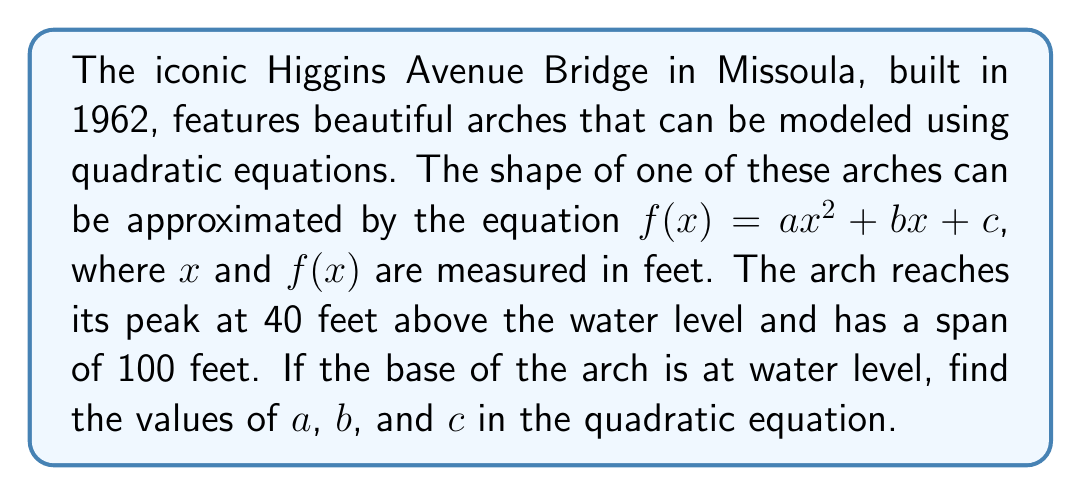Show me your answer to this math problem. Let's approach this step-by-step:

1) The arch is symmetrical, so its axis of symmetry is at the midpoint of its span. The span is 100 feet, so the axis of symmetry is at $x = 50$ feet.

2) We know three points on this parabola:
   - Left endpoint: $(0, 0)$
   - Vertex: $(50, 40)$
   - Right endpoint: $(100, 0)$

3) For a quadratic function $f(x) = ax^2 + bx + c$, the axis of symmetry is given by $x = -\frac{b}{2a}$. Since we know the axis of symmetry is at $x = 50$, we can write:

   $$50 = -\frac{b}{2a}$$

4) The vertex form of a quadratic function is $f(x) = a(x - h)^2 + k$, where $(h, k)$ is the vertex. Using our vertex $(50, 40)$, we can write:

   $$f(x) = a(x - 50)^2 + 40$$

5) Expanding this:

   $$f(x) = a(x^2 - 100x + 2500) + 40$$
   $$f(x) = ax^2 - 100ax + 2500a + 40$$

6) Comparing this to our original form $ax^2 + bx + c$, we can see that:

   $$b = -100a$$
   $$c = 2500a + 40$$

7) Now, let's use the point $(0, 0)$ to find $a$:

   $$0 = a(0)^2 + b(0) + c$$
   $$0 = 2500a + 40$$
   $$-40 = 2500a$$
   $$a = -\frac{1}{62.5} = -0.016$$

8) Now we can find $b$ and $c$:

   $$b = -100a = -100(-0.016) = 1.6$$
   $$c = 2500a + 40 = 2500(-0.016) + 40 = 0$$

Therefore, the quadratic equation modeling the arch is:

$$f(x) = -0.016x^2 + 1.6x$$
Answer: $a = -0.016$, $b = 1.6$, $c = 0$ 